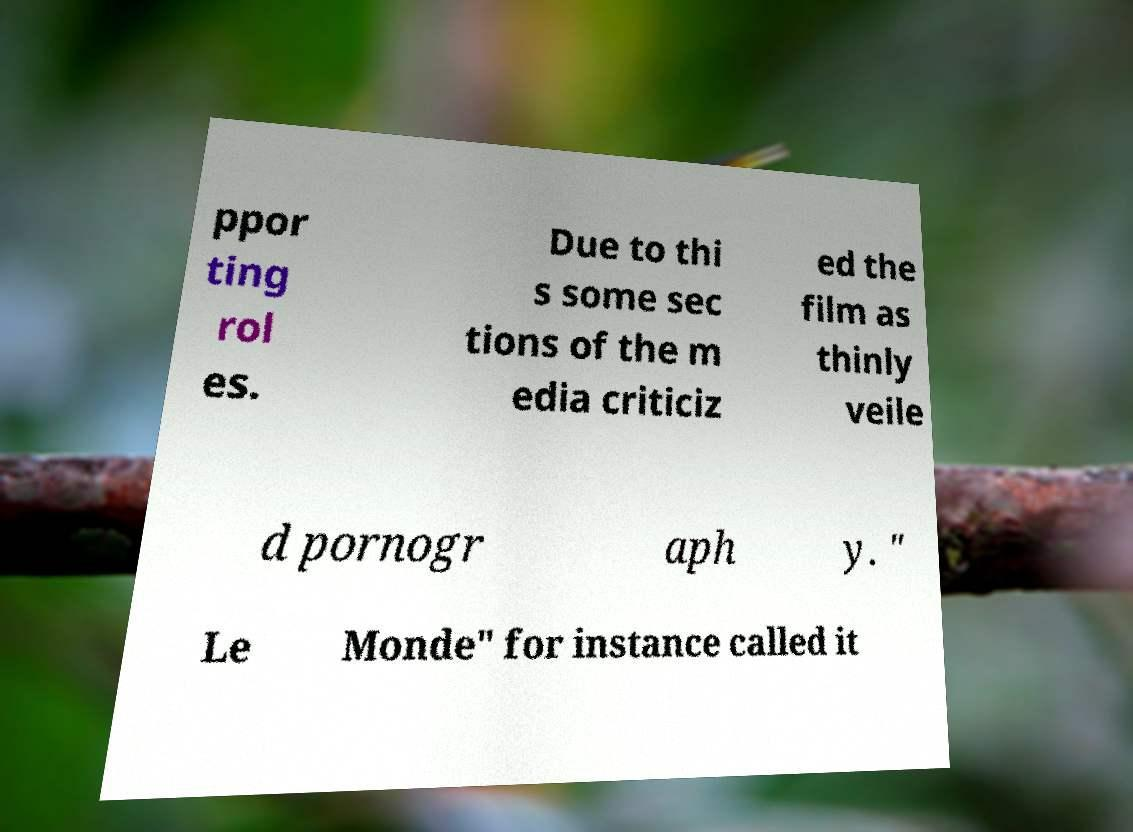Can you read and provide the text displayed in the image?This photo seems to have some interesting text. Can you extract and type it out for me? ppor ting rol es. Due to thi s some sec tions of the m edia criticiz ed the film as thinly veile d pornogr aph y. " Le Monde" for instance called it 